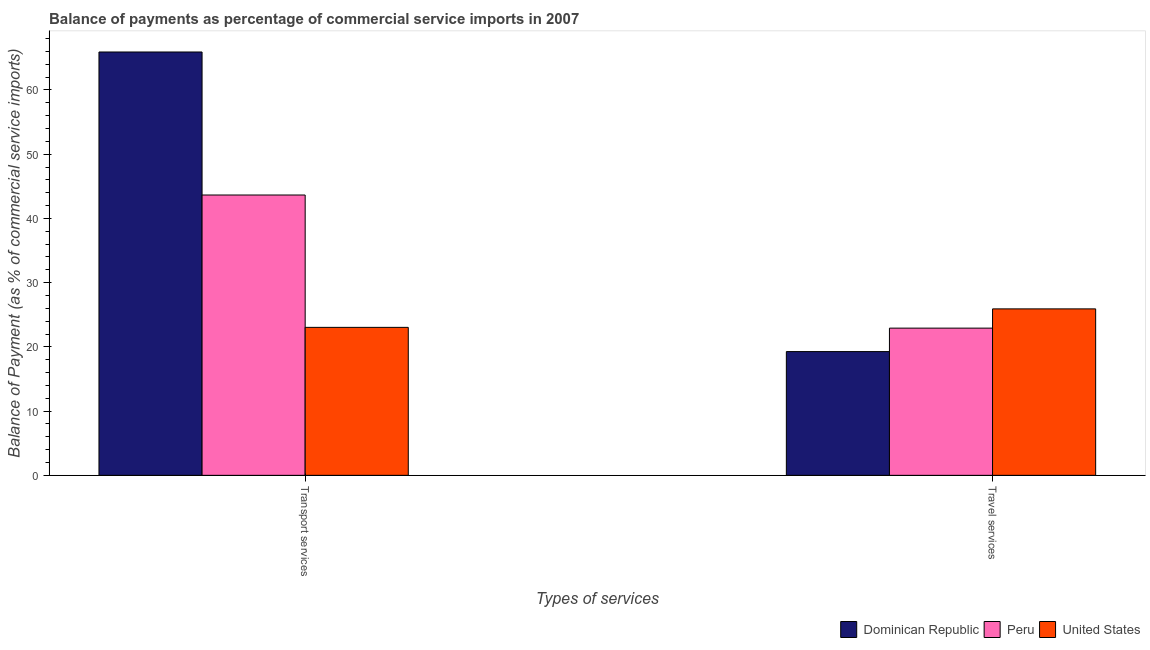How many groups of bars are there?
Give a very brief answer. 2. Are the number of bars on each tick of the X-axis equal?
Your answer should be compact. Yes. What is the label of the 2nd group of bars from the left?
Make the answer very short. Travel services. What is the balance of payments of transport services in Peru?
Your answer should be very brief. 43.65. Across all countries, what is the maximum balance of payments of transport services?
Provide a short and direct response. 65.92. Across all countries, what is the minimum balance of payments of travel services?
Your answer should be very brief. 19.27. In which country was the balance of payments of travel services maximum?
Ensure brevity in your answer.  United States. In which country was the balance of payments of transport services minimum?
Your response must be concise. United States. What is the total balance of payments of travel services in the graph?
Offer a terse response. 68.11. What is the difference between the balance of payments of transport services in Dominican Republic and that in United States?
Give a very brief answer. 42.88. What is the difference between the balance of payments of transport services in Dominican Republic and the balance of payments of travel services in Peru?
Your answer should be compact. 42.99. What is the average balance of payments of transport services per country?
Give a very brief answer. 44.2. What is the difference between the balance of payments of travel services and balance of payments of transport services in Dominican Republic?
Your answer should be very brief. -46.65. What is the ratio of the balance of payments of travel services in Peru to that in Dominican Republic?
Give a very brief answer. 1.19. What does the 1st bar from the left in Transport services represents?
Keep it short and to the point. Dominican Republic. What does the 3rd bar from the right in Travel services represents?
Offer a terse response. Dominican Republic. Are all the bars in the graph horizontal?
Keep it short and to the point. No. Are the values on the major ticks of Y-axis written in scientific E-notation?
Your answer should be compact. No. Does the graph contain grids?
Your answer should be compact. No. How many legend labels are there?
Give a very brief answer. 3. What is the title of the graph?
Offer a very short reply. Balance of payments as percentage of commercial service imports in 2007. Does "Middle East & North Africa (developing only)" appear as one of the legend labels in the graph?
Ensure brevity in your answer.  No. What is the label or title of the X-axis?
Offer a terse response. Types of services. What is the label or title of the Y-axis?
Provide a short and direct response. Balance of Payment (as % of commercial service imports). What is the Balance of Payment (as % of commercial service imports) in Dominican Republic in Transport services?
Give a very brief answer. 65.92. What is the Balance of Payment (as % of commercial service imports) of Peru in Transport services?
Your answer should be very brief. 43.65. What is the Balance of Payment (as % of commercial service imports) in United States in Transport services?
Make the answer very short. 23.04. What is the Balance of Payment (as % of commercial service imports) of Dominican Republic in Travel services?
Provide a short and direct response. 19.27. What is the Balance of Payment (as % of commercial service imports) of Peru in Travel services?
Ensure brevity in your answer.  22.92. What is the Balance of Payment (as % of commercial service imports) in United States in Travel services?
Make the answer very short. 25.92. Across all Types of services, what is the maximum Balance of Payment (as % of commercial service imports) in Dominican Republic?
Give a very brief answer. 65.92. Across all Types of services, what is the maximum Balance of Payment (as % of commercial service imports) of Peru?
Your response must be concise. 43.65. Across all Types of services, what is the maximum Balance of Payment (as % of commercial service imports) of United States?
Your response must be concise. 25.92. Across all Types of services, what is the minimum Balance of Payment (as % of commercial service imports) in Dominican Republic?
Provide a short and direct response. 19.27. Across all Types of services, what is the minimum Balance of Payment (as % of commercial service imports) of Peru?
Provide a short and direct response. 22.92. Across all Types of services, what is the minimum Balance of Payment (as % of commercial service imports) of United States?
Offer a very short reply. 23.04. What is the total Balance of Payment (as % of commercial service imports) in Dominican Republic in the graph?
Your response must be concise. 85.18. What is the total Balance of Payment (as % of commercial service imports) of Peru in the graph?
Your answer should be very brief. 66.57. What is the total Balance of Payment (as % of commercial service imports) of United States in the graph?
Offer a very short reply. 48.96. What is the difference between the Balance of Payment (as % of commercial service imports) in Dominican Republic in Transport services and that in Travel services?
Offer a terse response. 46.65. What is the difference between the Balance of Payment (as % of commercial service imports) of Peru in Transport services and that in Travel services?
Give a very brief answer. 20.73. What is the difference between the Balance of Payment (as % of commercial service imports) of United States in Transport services and that in Travel services?
Make the answer very short. -2.88. What is the difference between the Balance of Payment (as % of commercial service imports) in Dominican Republic in Transport services and the Balance of Payment (as % of commercial service imports) in Peru in Travel services?
Ensure brevity in your answer.  42.99. What is the difference between the Balance of Payment (as % of commercial service imports) of Dominican Republic in Transport services and the Balance of Payment (as % of commercial service imports) of United States in Travel services?
Provide a short and direct response. 40. What is the difference between the Balance of Payment (as % of commercial service imports) in Peru in Transport services and the Balance of Payment (as % of commercial service imports) in United States in Travel services?
Your answer should be compact. 17.73. What is the average Balance of Payment (as % of commercial service imports) in Dominican Republic per Types of services?
Make the answer very short. 42.59. What is the average Balance of Payment (as % of commercial service imports) in Peru per Types of services?
Offer a very short reply. 33.28. What is the average Balance of Payment (as % of commercial service imports) of United States per Types of services?
Your answer should be compact. 24.48. What is the difference between the Balance of Payment (as % of commercial service imports) in Dominican Republic and Balance of Payment (as % of commercial service imports) in Peru in Transport services?
Your answer should be compact. 22.27. What is the difference between the Balance of Payment (as % of commercial service imports) of Dominican Republic and Balance of Payment (as % of commercial service imports) of United States in Transport services?
Offer a terse response. 42.88. What is the difference between the Balance of Payment (as % of commercial service imports) of Peru and Balance of Payment (as % of commercial service imports) of United States in Transport services?
Provide a short and direct response. 20.61. What is the difference between the Balance of Payment (as % of commercial service imports) in Dominican Republic and Balance of Payment (as % of commercial service imports) in Peru in Travel services?
Offer a very short reply. -3.65. What is the difference between the Balance of Payment (as % of commercial service imports) of Dominican Republic and Balance of Payment (as % of commercial service imports) of United States in Travel services?
Give a very brief answer. -6.65. What is the difference between the Balance of Payment (as % of commercial service imports) in Peru and Balance of Payment (as % of commercial service imports) in United States in Travel services?
Your response must be concise. -3. What is the ratio of the Balance of Payment (as % of commercial service imports) of Dominican Republic in Transport services to that in Travel services?
Your answer should be compact. 3.42. What is the ratio of the Balance of Payment (as % of commercial service imports) in Peru in Transport services to that in Travel services?
Your answer should be very brief. 1.9. What is the ratio of the Balance of Payment (as % of commercial service imports) in United States in Transport services to that in Travel services?
Offer a terse response. 0.89. What is the difference between the highest and the second highest Balance of Payment (as % of commercial service imports) of Dominican Republic?
Give a very brief answer. 46.65. What is the difference between the highest and the second highest Balance of Payment (as % of commercial service imports) of Peru?
Your answer should be very brief. 20.73. What is the difference between the highest and the second highest Balance of Payment (as % of commercial service imports) of United States?
Offer a terse response. 2.88. What is the difference between the highest and the lowest Balance of Payment (as % of commercial service imports) in Dominican Republic?
Provide a short and direct response. 46.65. What is the difference between the highest and the lowest Balance of Payment (as % of commercial service imports) in Peru?
Give a very brief answer. 20.73. What is the difference between the highest and the lowest Balance of Payment (as % of commercial service imports) of United States?
Your answer should be compact. 2.88. 